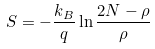Convert formula to latex. <formula><loc_0><loc_0><loc_500><loc_500>S = - \frac { k _ { B } } { q } \ln \frac { 2 N - \rho } { \rho }</formula> 